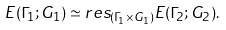Convert formula to latex. <formula><loc_0><loc_0><loc_500><loc_500>E ( \Gamma _ { 1 } ; G _ { 1 } ) \simeq r e s _ { ( \Gamma _ { 1 } \times G _ { 1 } ) } E ( \Gamma _ { 2 } ; G _ { 2 } ) .</formula> 